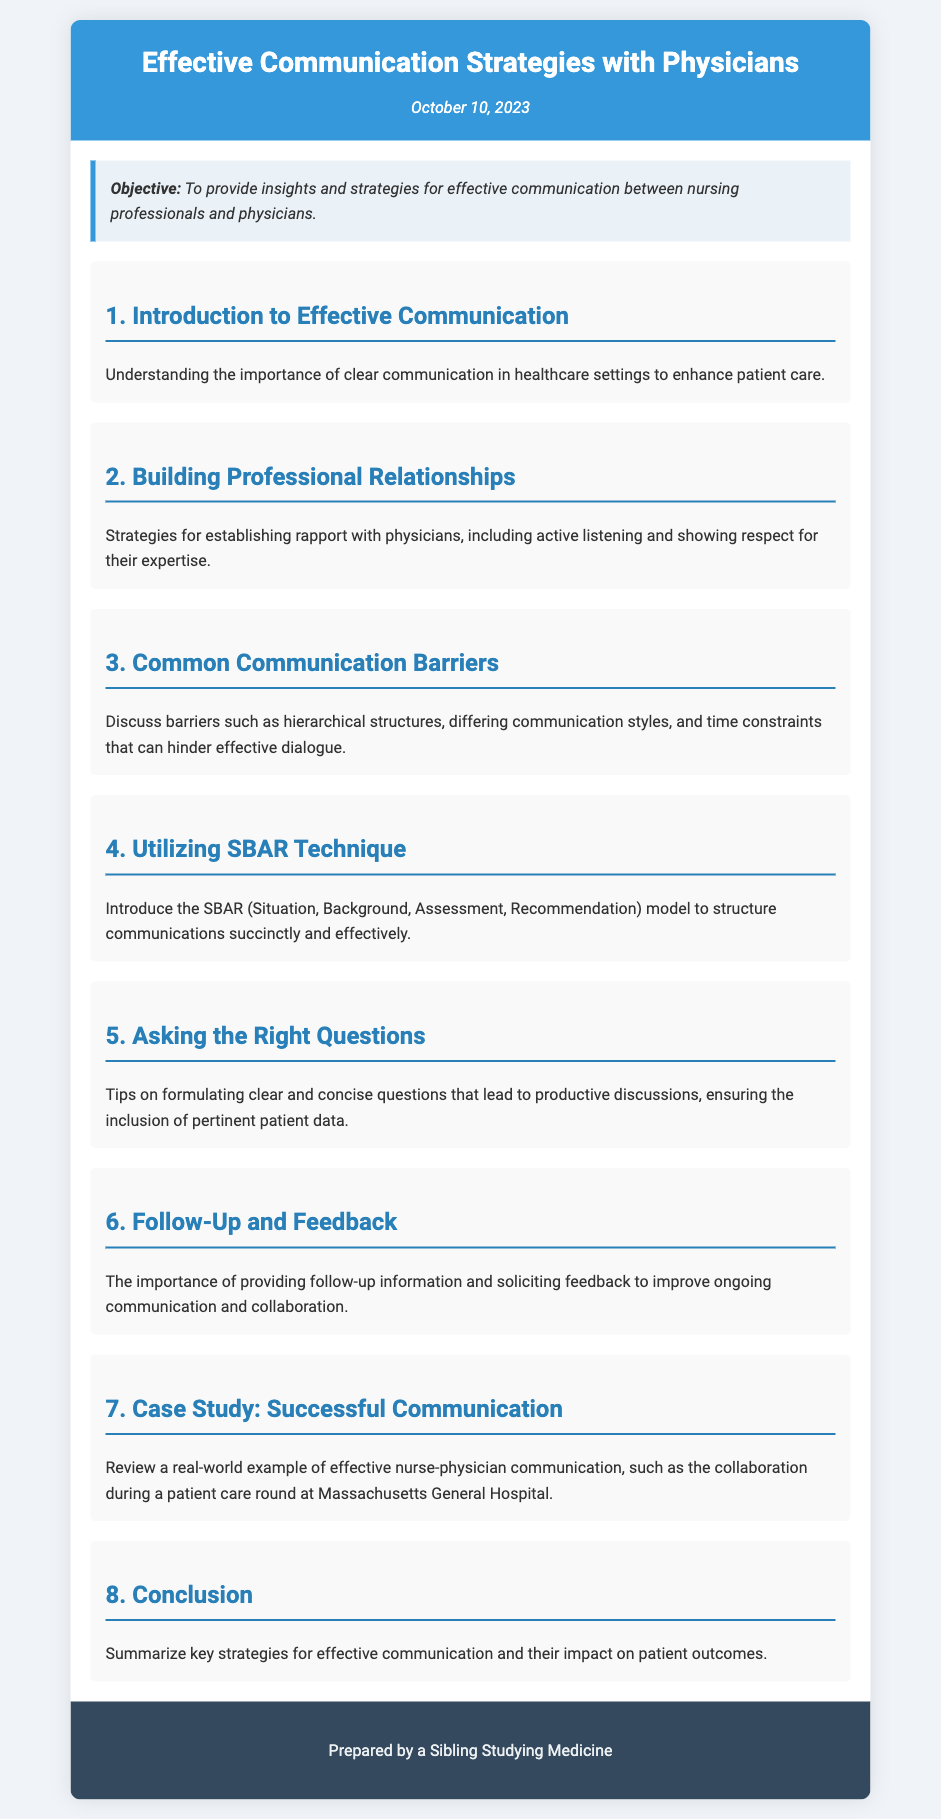What is the document's title? The title is provided at the top of the document and indicates the focus of the agenda, which is communication strategies with physicians.
Answer: Effective Communication Strategies with Physicians What is the date of the document? The date is mentioned right below the title and indicates when the agenda was prepared.
Answer: October 10, 2023 What is the objective of the document? The objective is presented in a separate section and outlines the purpose of the agenda.
Answer: To provide insights and strategies for effective communication between nursing professionals and physicians What communication model is introduced in the document? The SBAR model is highlighted as a key communication technique discussed in the agenda.
Answer: SBAR Which section discusses common barriers to communication? The relevant section outlines obstacles that can hinder effective dialogue between nurses and physicians.
Answer: Common Communication Barriers How many sections are listed in the document? The sections listed provide an organized structure to the document, detailing various communication aspects.
Answer: Eight What real-world example is included in the document? A specific case study is presented to illustrate successful nurse-physician communication.
Answer: Massachusetts General Hospital What is the last section of the document titled? The last section provides a summary of the strategies discussed throughout the agenda.
Answer: Conclusion 